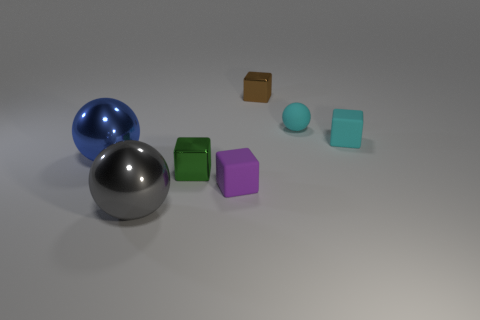Subtract all blue blocks. Subtract all green cylinders. How many blocks are left? 4 Add 2 cyan objects. How many objects exist? 9 Subtract all spheres. How many objects are left? 4 Add 7 metal balls. How many metal balls are left? 9 Add 3 small red rubber objects. How many small red rubber objects exist? 3 Subtract 0 yellow cylinders. How many objects are left? 7 Subtract all green blocks. Subtract all metallic spheres. How many objects are left? 4 